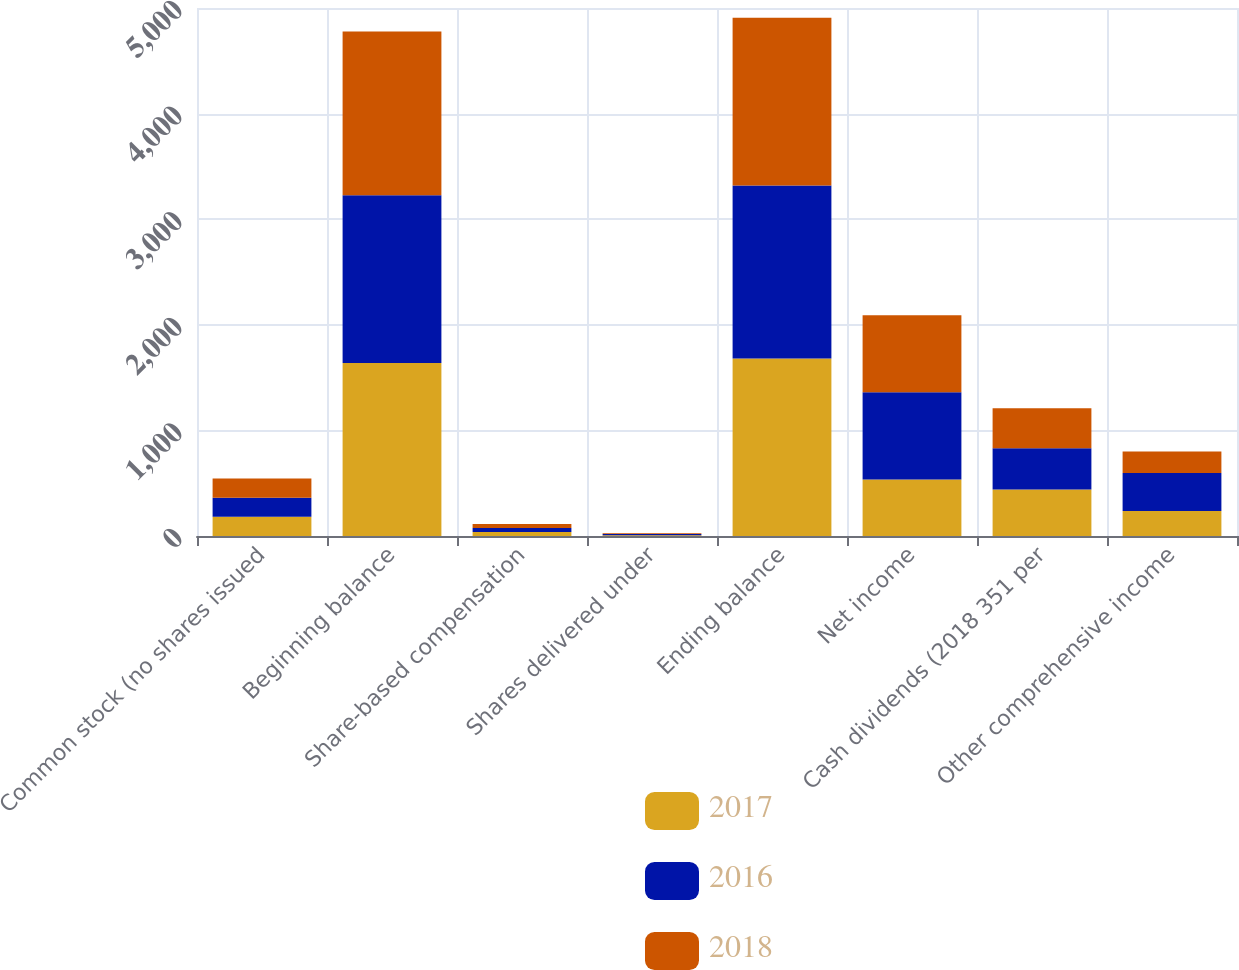<chart> <loc_0><loc_0><loc_500><loc_500><stacked_bar_chart><ecel><fcel>Common stock (no shares issued<fcel>Beginning balance<fcel>Share-based compensation<fcel>Shares delivered under<fcel>Ending balance<fcel>Net income<fcel>Cash dividends (2018 351 per<fcel>Other comprehensive income<nl><fcel>2017<fcel>181.4<fcel>1638<fcel>37.3<fcel>6.1<fcel>1681.4<fcel>535.5<fcel>440.8<fcel>237.3<nl><fcel>2016<fcel>181.4<fcel>1588.2<fcel>37.4<fcel>12.4<fcel>1638<fcel>825.7<fcel>390.7<fcel>359.6<nl><fcel>2018<fcel>181.4<fcel>1552.1<fcel>39.5<fcel>6.7<fcel>1588.2<fcel>729.7<fcel>378.2<fcel>204.2<nl></chart> 